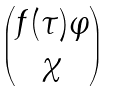<formula> <loc_0><loc_0><loc_500><loc_500>\begin{pmatrix} f ( \tau ) \varphi \\ \chi \end{pmatrix}</formula> 